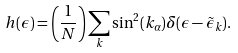Convert formula to latex. <formula><loc_0><loc_0><loc_500><loc_500>h ( \epsilon ) = \left ( \frac { 1 } { N } \right ) \sum _ { k } \sin ^ { 2 } ( k _ { \alpha } ) \delta ( \epsilon - \tilde { \epsilon } _ { k } ) .</formula> 